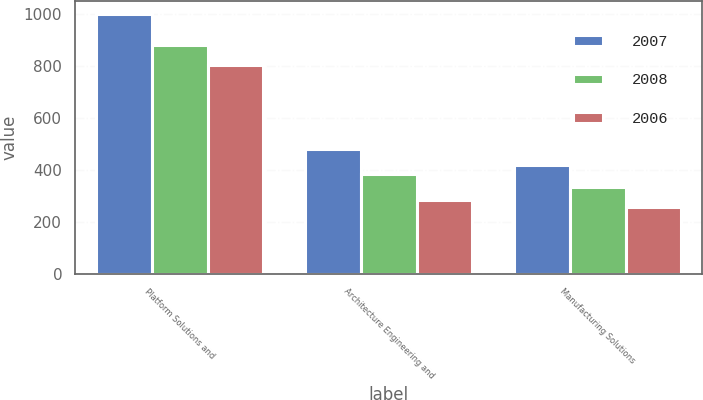Convert chart to OTSL. <chart><loc_0><loc_0><loc_500><loc_500><stacked_bar_chart><ecel><fcel>Platform Solutions and<fcel>Architecture Engineering and<fcel>Manufacturing Solutions<nl><fcel>2007<fcel>997.1<fcel>480<fcel>418<nl><fcel>2008<fcel>878.9<fcel>382.4<fcel>333.3<nl><fcel>2006<fcel>803.3<fcel>284.3<fcel>256.9<nl></chart> 